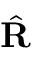Convert formula to latex. <formula><loc_0><loc_0><loc_500><loc_500>\hat { R }</formula> 